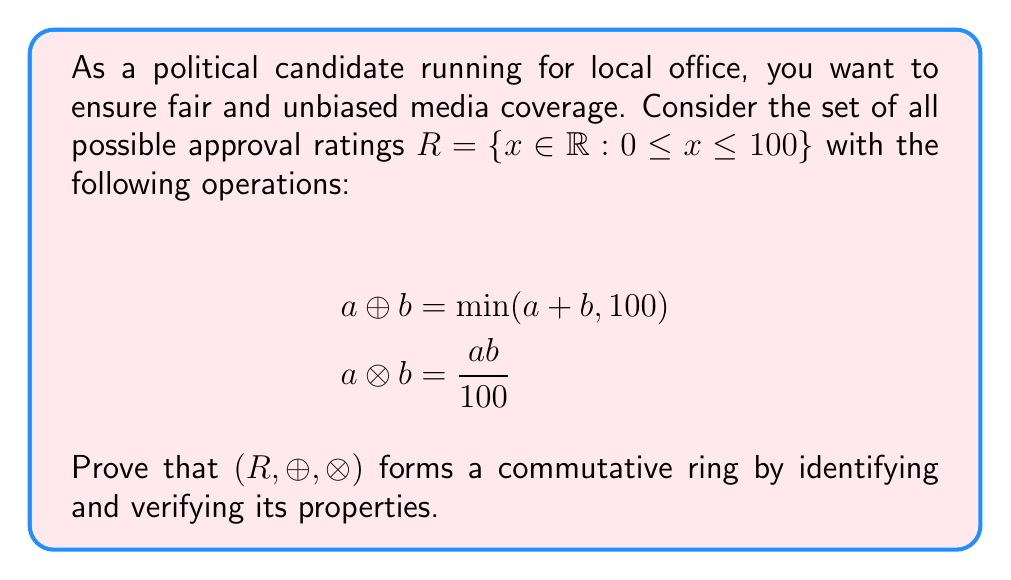Show me your answer to this math problem. To prove that $(R, \oplus, \otimes)$ is a commutative ring, we need to verify the following properties:

1. $(R, \oplus)$ is an abelian group:
   a) Closure: For any $a, b \in R$, $a \oplus b = \min(a + b, 100) \in R$
   b) Associativity: $(a \oplus b) \oplus c = a \oplus (b \oplus c)$ for all $a, b, c \in R$
   c) Commutativity: $a \oplus b = b \oplus a$ for all $a, b \in R$
   d) Identity: $0 \oplus a = a \oplus 0 = a$ for all $a \in R$
   e) Inverse: For any $a \in R$, there exists $-a \in R$ such that $a \oplus (-a) = 0$

2. $(R, \otimes)$ is commutative:
   $a \otimes b = \frac{ab}{100} = \frac{ba}{100} = b \otimes a$ for all $a, b \in R$

3. $(R, \otimes)$ is associative:
   $(a \otimes b) \otimes c = \frac{(ab/100)c}{100} = \frac{abc}{10000} = \frac{a(bc/100)}{100} = a \otimes (b \otimes c)$

4. Distributive property:
   $a \otimes (b \oplus c) = (a \otimes b) \oplus (a \otimes c)$ for all $a, b, c \in R$

Verification of these properties:

1a-1c) Closure, associativity, and commutativity are trivially satisfied by the definition of $\oplus$.

1d) Identity: $0 \oplus a = \min(0 + a, 100) = a$ for all $a \in R$.

1e) Inverse: For any $a \in R$, $-a = 0$ serves as the additive inverse since $a \oplus 0 = \min(a + 0, 100) = a$.

2-3) Commutativity and associativity of $\otimes$ are satisfied as shown above.

4) Distributive property:
   Let $a, b, c \in R$. Then:
   $a \otimes (b \oplus c) = a \otimes \min(b + c, 100) = \min(\frac{a(b+c)}{100}, a)$
   $(a \otimes b) \oplus (a \otimes c) = \min(\frac{ab}{100} + \frac{ac}{100}, 100) = \min(\frac{a(b+c)}{100}, 100)$

   Since $\frac{a(b+c)}{100} \leq a$ and $\frac{a(b+c)}{100} \leq 100$, the distributive property holds.

Therefore, $(R, \oplus, \otimes)$ satisfies all the properties of a commutative ring.
Answer: $(R, \oplus, \otimes)$ is a commutative ring. 